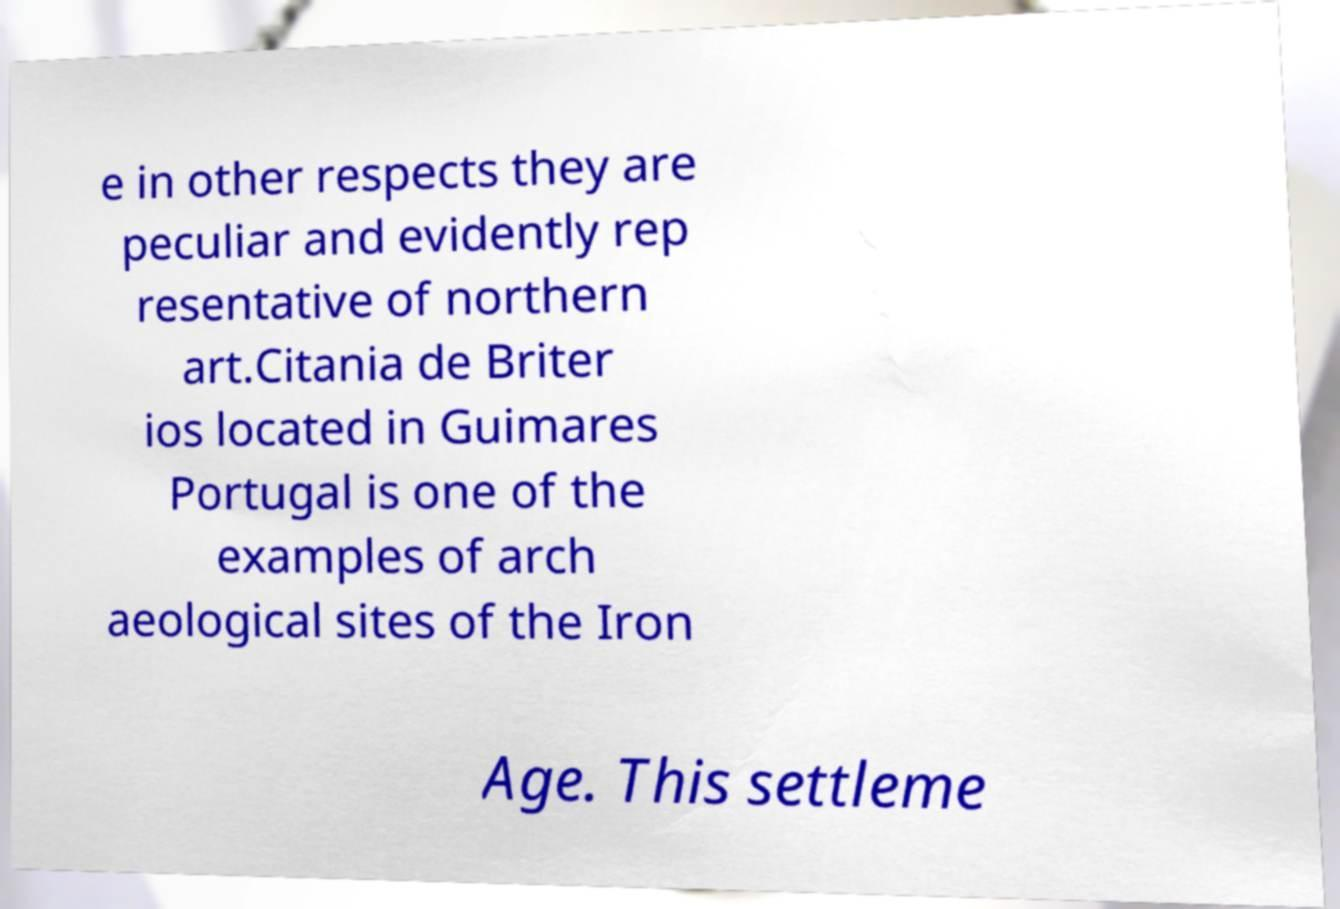Could you assist in decoding the text presented in this image and type it out clearly? e in other respects they are peculiar and evidently rep resentative of northern art.Citania de Briter ios located in Guimares Portugal is one of the examples of arch aeological sites of the Iron Age. This settleme 